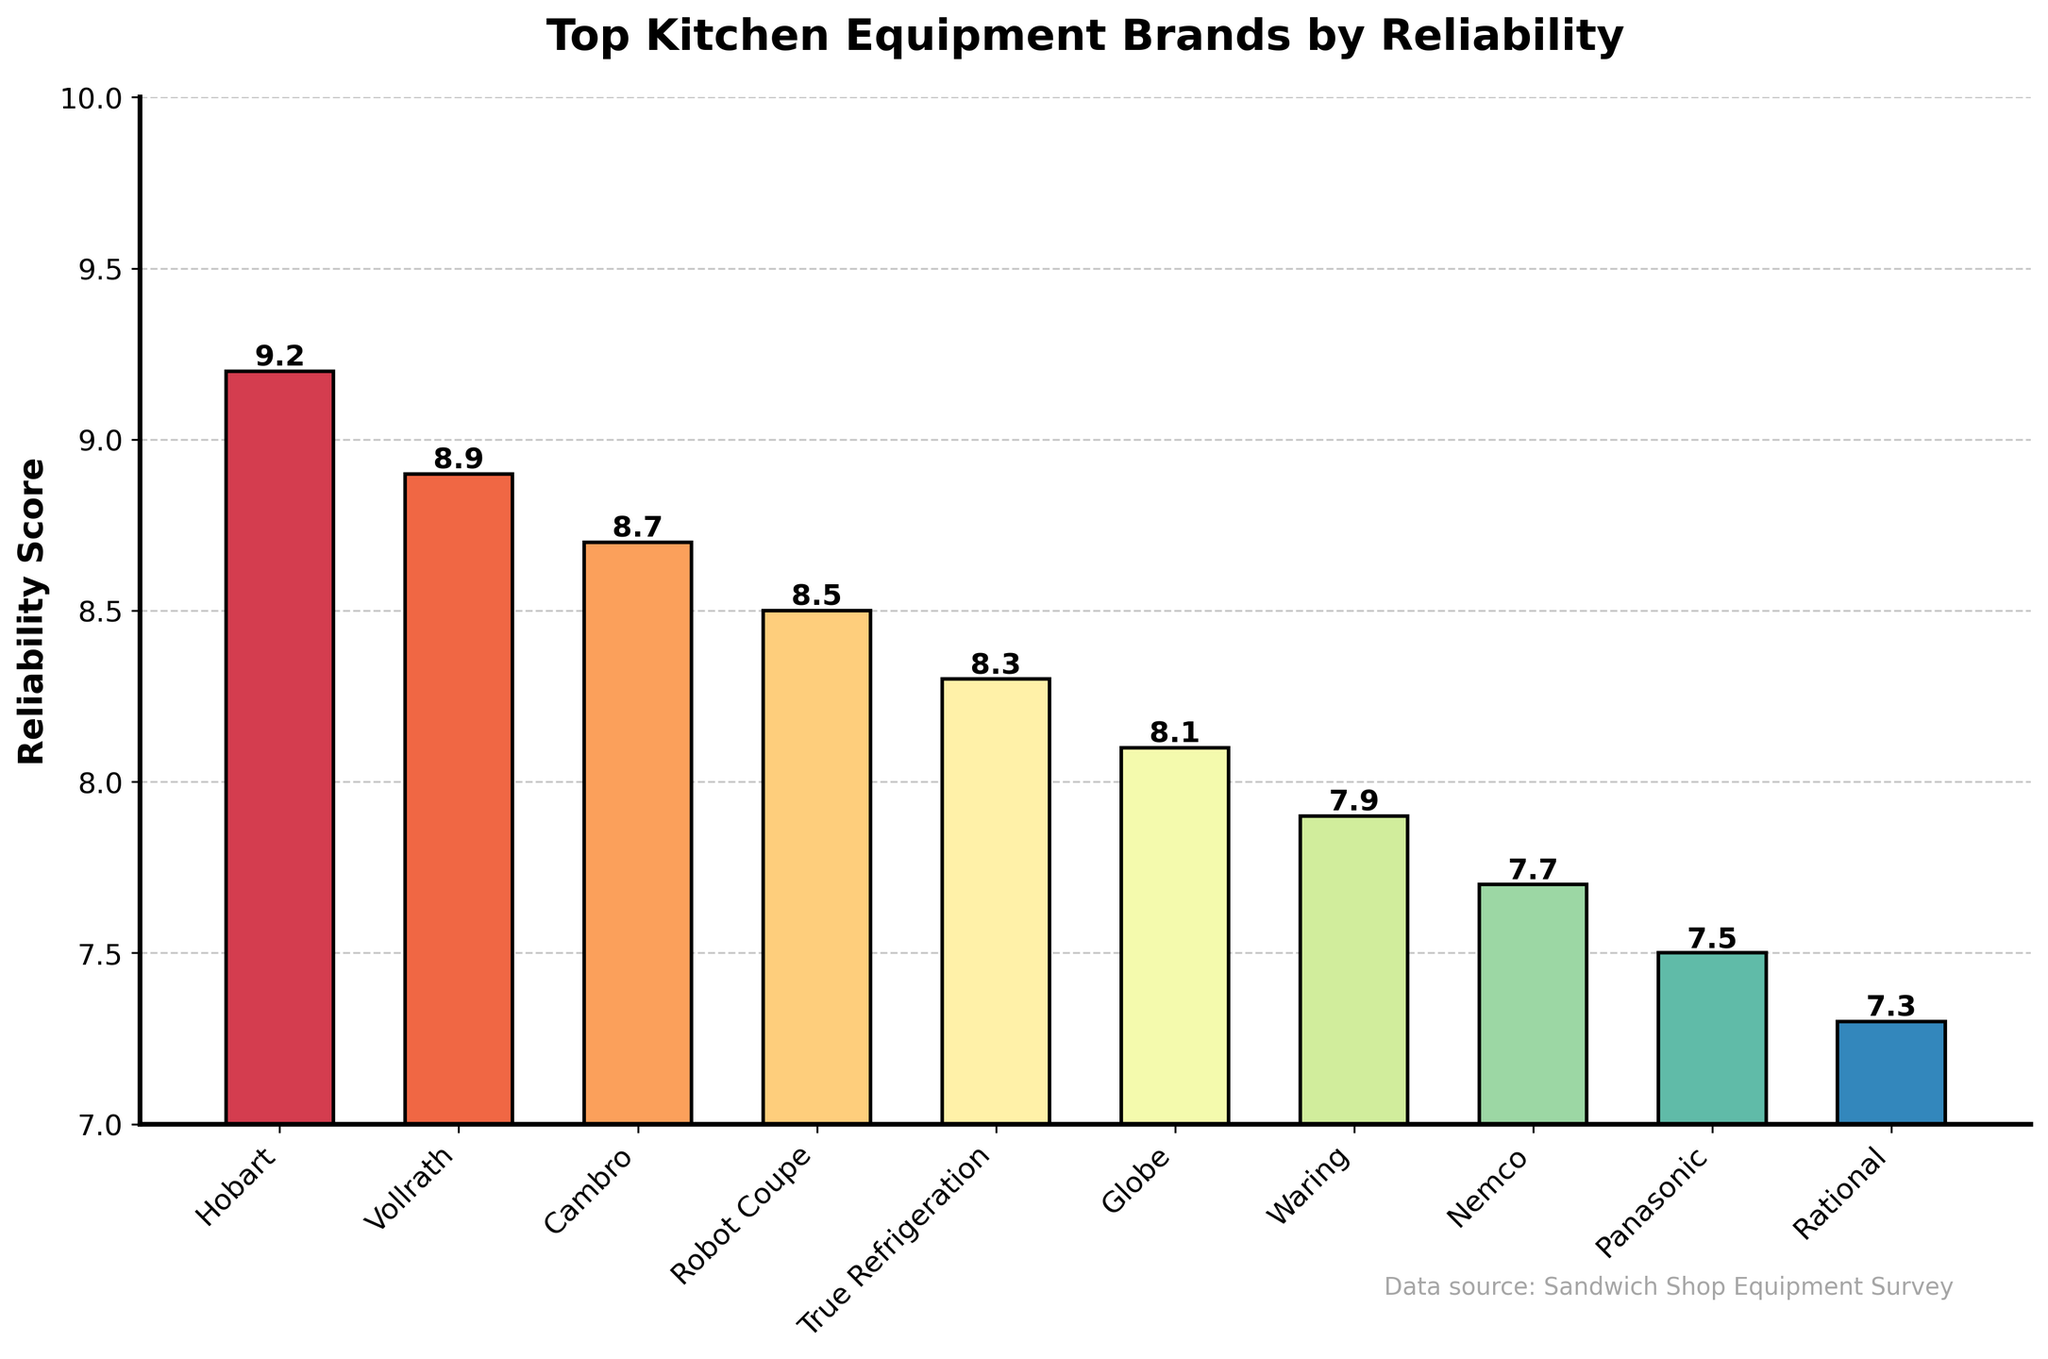which brand has the highest reliability score? The highest bar in the chart corresponds to Hobart, indicating it has the highest reliability score.
Answer: Hobart how many brands have a reliability score higher than 8.5? The brands with scores higher than 8.5 are Hobart, Vollrath, and Cambro. That's a total of three brands.
Answer: 3 what's the difference in reliability score between the top-ranked and the lowest-ranked brand? The top-ranked brand is Hobart with a score of 9.2, and the lowest-ranked brand represented in the plot should be Rational with a score of 7.3. The difference is 9.2 - 7.3 = 1.9.
Answer: 1.9 what's the average reliability score of the top 5 brands? The top 5 brands are Hobart (9.2), Vollrath (8.9), Cambro (8.7), Robot Coupe (8.5), and True Refrigeration (8.3). The sum is 9.2 + 8.9 + 8.7 + 8.5 + 8.3 = 43.6, and the average is 43.6 / 5 = 8.72
Answer: 8.72 which brand has a reliability score closest to the median score of the top 5 brands? The top 5 brands and their scores are: Hobart (9.2), Vollrath (8.9), Cambro (8.7), Robot Coupe (8.5), and True Refrigeration (8.3). The median score is 8.7. Cambro, with a score of 8.7, is exactly at the median.
Answer: Cambro compare the reliability score of Cambro and Waring Cambro has a reliability score of 8.7, and Waring has a score of 7.9. Comparing these scores, Cambro's score is higher.
Answer: Cambro which brand has a reliability score that is an exact whole number? None of the brands listed have reliability scores that are exact whole numbers; they all have decimal points.
Answer: None which brand's bar is the second highest in the chart? The second highest bar corresponds to Vollrath, indicating it is the second highest ranking in reliability.
Answer: Vollrath how much higher is Hobart's score compared to Panasonic's? Hobart has a score of 9.2, and Panasonic has a score of 7.5. The difference is 9.2 - 7.5 = 1.7.
Answer: 1.7 what color is associated with the lowest-ranked brand in this chart? While the specific colors aren't specified in the question and can vary based on settings, the chart uses a spectral color scheme. The bar at the far right is usually represented with the color assigned to the lowest index in the colormap. Since Rational is on the far right, that bar will have the color corresponding to the lowest value on the spectral gradient.
Answer: Spectral Color (varies) 